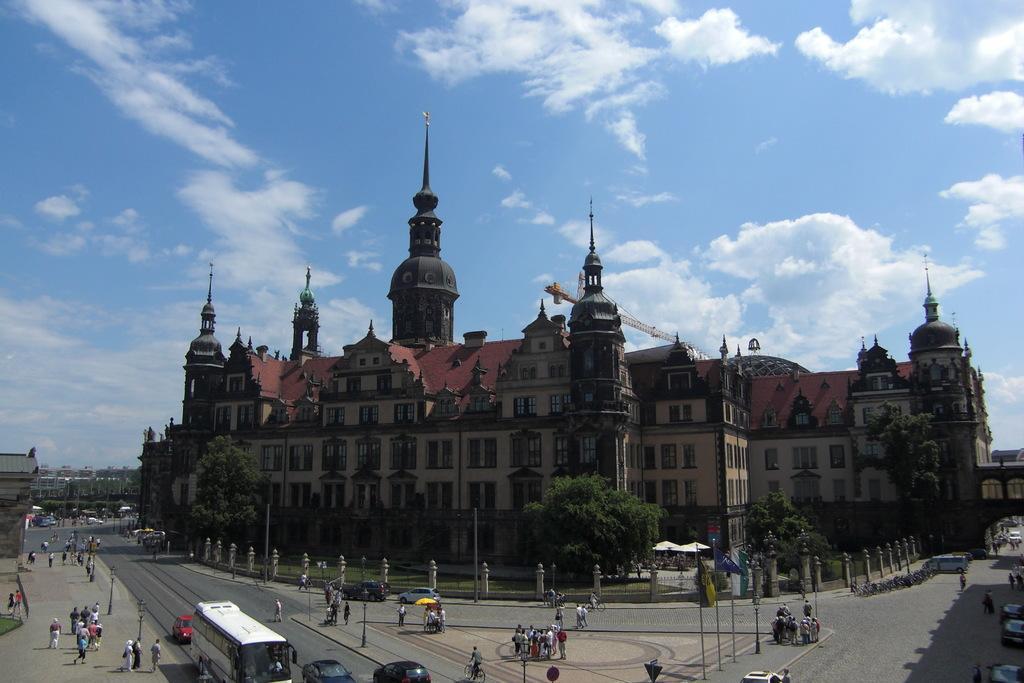Could you give a brief overview of what you see in this image? Sky is cloudy. Here we can see buildings. To these buildings there are windows. In-front of these buildings there are trees, people, flags and vehicles. 